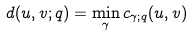Convert formula to latex. <formula><loc_0><loc_0><loc_500><loc_500>d ( { u } , { v } ; q ) = \min _ { \gamma } c _ { \gamma ; q } ( { u } , { v } )</formula> 